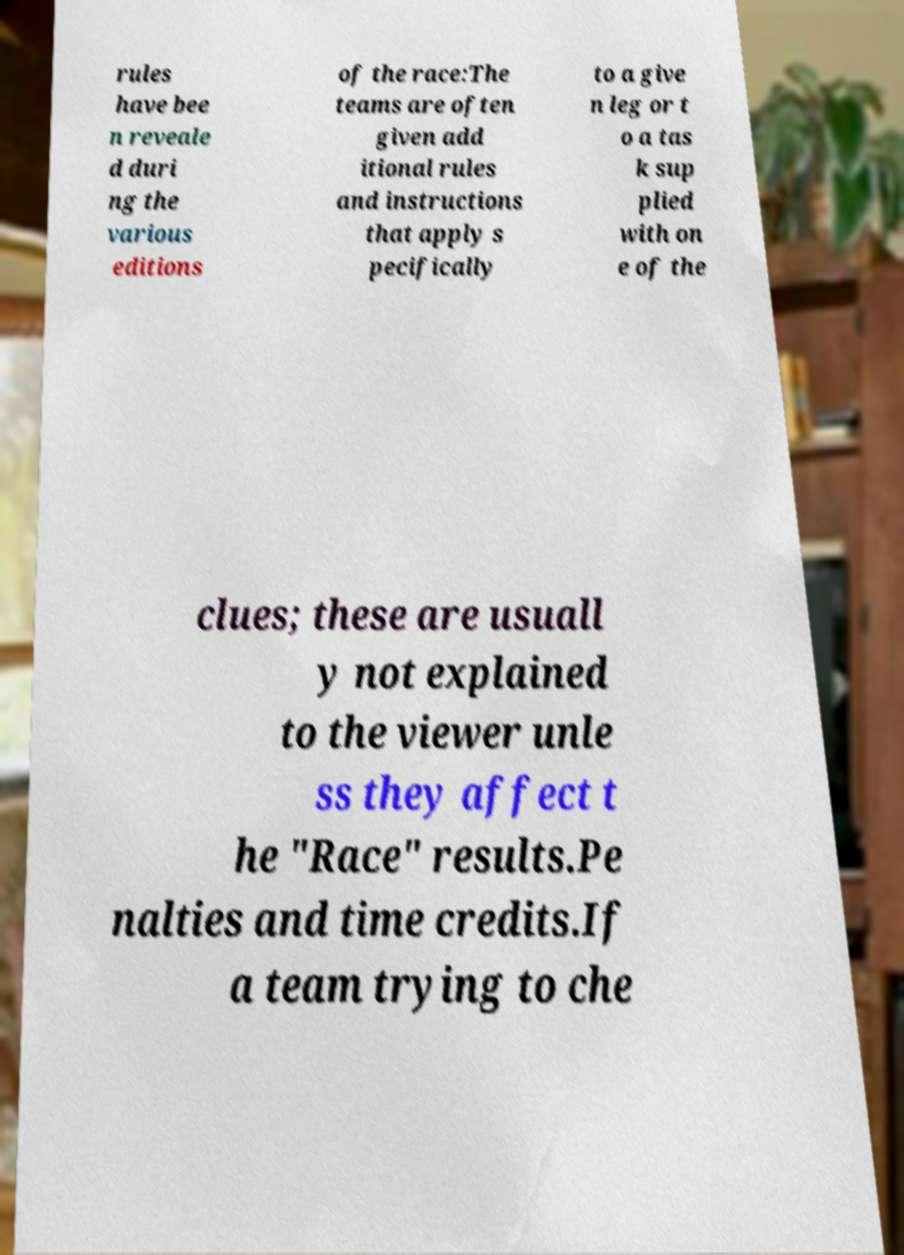What messages or text are displayed in this image? I need them in a readable, typed format. rules have bee n reveale d duri ng the various editions of the race:The teams are often given add itional rules and instructions that apply s pecifically to a give n leg or t o a tas k sup plied with on e of the clues; these are usuall y not explained to the viewer unle ss they affect t he "Race" results.Pe nalties and time credits.If a team trying to che 